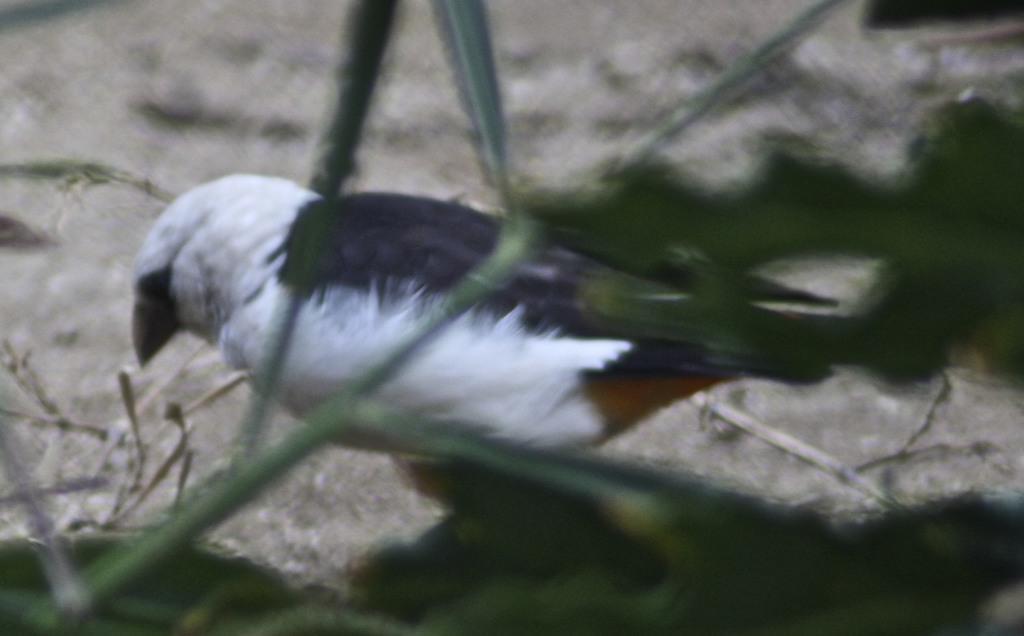Can you describe this image briefly? In this picture we can see a bird and in the background we can see grass on the ground and it is blurry. 